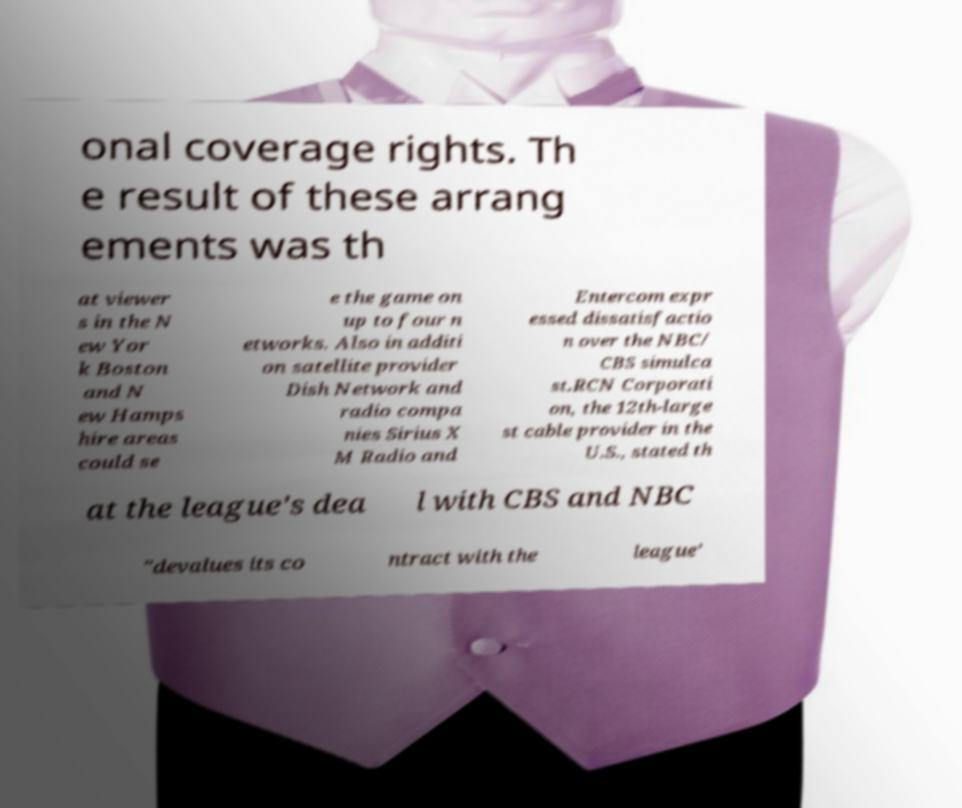For documentation purposes, I need the text within this image transcribed. Could you provide that? onal coverage rights. Th e result of these arrang ements was th at viewer s in the N ew Yor k Boston and N ew Hamps hire areas could se e the game on up to four n etworks. Also in additi on satellite provider Dish Network and radio compa nies Sirius X M Radio and Entercom expr essed dissatisfactio n over the NBC/ CBS simulca st.RCN Corporati on, the 12th-large st cable provider in the U.S., stated th at the league's dea l with CBS and NBC "devalues its co ntract with the league’ 